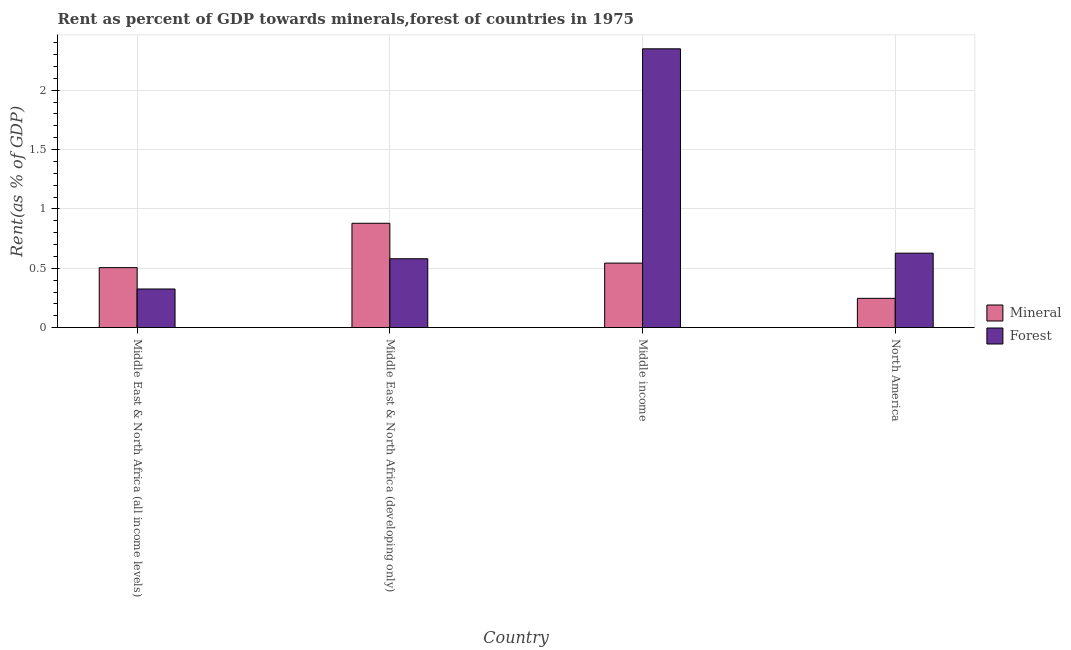How many different coloured bars are there?
Offer a terse response. 2. Are the number of bars per tick equal to the number of legend labels?
Your answer should be compact. Yes. Are the number of bars on each tick of the X-axis equal?
Offer a terse response. Yes. How many bars are there on the 3rd tick from the left?
Provide a succinct answer. 2. How many bars are there on the 4th tick from the right?
Provide a short and direct response. 2. What is the label of the 2nd group of bars from the left?
Offer a very short reply. Middle East & North Africa (developing only). What is the forest rent in Middle East & North Africa (all income levels)?
Give a very brief answer. 0.33. Across all countries, what is the maximum forest rent?
Give a very brief answer. 2.35. Across all countries, what is the minimum mineral rent?
Offer a terse response. 0.25. In which country was the mineral rent maximum?
Your response must be concise. Middle East & North Africa (developing only). In which country was the forest rent minimum?
Make the answer very short. Middle East & North Africa (all income levels). What is the total mineral rent in the graph?
Your answer should be very brief. 2.18. What is the difference between the mineral rent in Middle East & North Africa (all income levels) and that in Middle income?
Offer a very short reply. -0.04. What is the difference between the mineral rent in Middle East & North Africa (all income levels) and the forest rent in North America?
Offer a terse response. -0.12. What is the average forest rent per country?
Provide a succinct answer. 0.97. What is the difference between the mineral rent and forest rent in North America?
Give a very brief answer. -0.38. What is the ratio of the forest rent in Middle East & North Africa (developing only) to that in Middle income?
Provide a short and direct response. 0.25. What is the difference between the highest and the second highest forest rent?
Ensure brevity in your answer.  1.72. What is the difference between the highest and the lowest forest rent?
Provide a succinct answer. 2.02. In how many countries, is the forest rent greater than the average forest rent taken over all countries?
Provide a short and direct response. 1. Is the sum of the mineral rent in Middle income and North America greater than the maximum forest rent across all countries?
Keep it short and to the point. No. What does the 1st bar from the left in Middle East & North Africa (all income levels) represents?
Provide a short and direct response. Mineral. What does the 1st bar from the right in North America represents?
Ensure brevity in your answer.  Forest. What is the difference between two consecutive major ticks on the Y-axis?
Your response must be concise. 0.5. Are the values on the major ticks of Y-axis written in scientific E-notation?
Ensure brevity in your answer.  No. Does the graph contain grids?
Your answer should be compact. Yes. Where does the legend appear in the graph?
Give a very brief answer. Center right. How are the legend labels stacked?
Offer a terse response. Vertical. What is the title of the graph?
Ensure brevity in your answer.  Rent as percent of GDP towards minerals,forest of countries in 1975. Does "Automatic Teller Machines" appear as one of the legend labels in the graph?
Make the answer very short. No. What is the label or title of the Y-axis?
Provide a succinct answer. Rent(as % of GDP). What is the Rent(as % of GDP) in Mineral in Middle East & North Africa (all income levels)?
Make the answer very short. 0.51. What is the Rent(as % of GDP) in Forest in Middle East & North Africa (all income levels)?
Provide a short and direct response. 0.33. What is the Rent(as % of GDP) in Mineral in Middle East & North Africa (developing only)?
Keep it short and to the point. 0.88. What is the Rent(as % of GDP) in Forest in Middle East & North Africa (developing only)?
Your answer should be very brief. 0.58. What is the Rent(as % of GDP) of Mineral in Middle income?
Keep it short and to the point. 0.54. What is the Rent(as % of GDP) in Forest in Middle income?
Ensure brevity in your answer.  2.35. What is the Rent(as % of GDP) in Mineral in North America?
Give a very brief answer. 0.25. What is the Rent(as % of GDP) in Forest in North America?
Ensure brevity in your answer.  0.63. Across all countries, what is the maximum Rent(as % of GDP) of Mineral?
Keep it short and to the point. 0.88. Across all countries, what is the maximum Rent(as % of GDP) in Forest?
Keep it short and to the point. 2.35. Across all countries, what is the minimum Rent(as % of GDP) of Mineral?
Make the answer very short. 0.25. Across all countries, what is the minimum Rent(as % of GDP) in Forest?
Your response must be concise. 0.33. What is the total Rent(as % of GDP) in Mineral in the graph?
Keep it short and to the point. 2.17. What is the total Rent(as % of GDP) of Forest in the graph?
Make the answer very short. 3.88. What is the difference between the Rent(as % of GDP) of Mineral in Middle East & North Africa (all income levels) and that in Middle East & North Africa (developing only)?
Your answer should be compact. -0.37. What is the difference between the Rent(as % of GDP) of Forest in Middle East & North Africa (all income levels) and that in Middle East & North Africa (developing only)?
Offer a very short reply. -0.25. What is the difference between the Rent(as % of GDP) of Mineral in Middle East & North Africa (all income levels) and that in Middle income?
Ensure brevity in your answer.  -0.04. What is the difference between the Rent(as % of GDP) of Forest in Middle East & North Africa (all income levels) and that in Middle income?
Keep it short and to the point. -2.02. What is the difference between the Rent(as % of GDP) of Mineral in Middle East & North Africa (all income levels) and that in North America?
Your answer should be very brief. 0.26. What is the difference between the Rent(as % of GDP) of Forest in Middle East & North Africa (all income levels) and that in North America?
Your response must be concise. -0.3. What is the difference between the Rent(as % of GDP) in Mineral in Middle East & North Africa (developing only) and that in Middle income?
Provide a succinct answer. 0.34. What is the difference between the Rent(as % of GDP) of Forest in Middle East & North Africa (developing only) and that in Middle income?
Ensure brevity in your answer.  -1.77. What is the difference between the Rent(as % of GDP) in Mineral in Middle East & North Africa (developing only) and that in North America?
Offer a very short reply. 0.63. What is the difference between the Rent(as % of GDP) of Forest in Middle East & North Africa (developing only) and that in North America?
Keep it short and to the point. -0.05. What is the difference between the Rent(as % of GDP) of Mineral in Middle income and that in North America?
Provide a succinct answer. 0.3. What is the difference between the Rent(as % of GDP) of Forest in Middle income and that in North America?
Give a very brief answer. 1.72. What is the difference between the Rent(as % of GDP) in Mineral in Middle East & North Africa (all income levels) and the Rent(as % of GDP) in Forest in Middle East & North Africa (developing only)?
Offer a terse response. -0.07. What is the difference between the Rent(as % of GDP) of Mineral in Middle East & North Africa (all income levels) and the Rent(as % of GDP) of Forest in Middle income?
Offer a terse response. -1.84. What is the difference between the Rent(as % of GDP) of Mineral in Middle East & North Africa (all income levels) and the Rent(as % of GDP) of Forest in North America?
Make the answer very short. -0.12. What is the difference between the Rent(as % of GDP) of Mineral in Middle East & North Africa (developing only) and the Rent(as % of GDP) of Forest in Middle income?
Provide a short and direct response. -1.47. What is the difference between the Rent(as % of GDP) of Mineral in Middle East & North Africa (developing only) and the Rent(as % of GDP) of Forest in North America?
Make the answer very short. 0.25. What is the difference between the Rent(as % of GDP) in Mineral in Middle income and the Rent(as % of GDP) in Forest in North America?
Your response must be concise. -0.08. What is the average Rent(as % of GDP) in Mineral per country?
Make the answer very short. 0.54. What is the average Rent(as % of GDP) in Forest per country?
Your response must be concise. 0.97. What is the difference between the Rent(as % of GDP) of Mineral and Rent(as % of GDP) of Forest in Middle East & North Africa (all income levels)?
Provide a succinct answer. 0.18. What is the difference between the Rent(as % of GDP) of Mineral and Rent(as % of GDP) of Forest in Middle East & North Africa (developing only)?
Your response must be concise. 0.3. What is the difference between the Rent(as % of GDP) of Mineral and Rent(as % of GDP) of Forest in Middle income?
Keep it short and to the point. -1.8. What is the difference between the Rent(as % of GDP) of Mineral and Rent(as % of GDP) of Forest in North America?
Offer a very short reply. -0.38. What is the ratio of the Rent(as % of GDP) of Mineral in Middle East & North Africa (all income levels) to that in Middle East & North Africa (developing only)?
Ensure brevity in your answer.  0.57. What is the ratio of the Rent(as % of GDP) in Forest in Middle East & North Africa (all income levels) to that in Middle East & North Africa (developing only)?
Your response must be concise. 0.56. What is the ratio of the Rent(as % of GDP) in Mineral in Middle East & North Africa (all income levels) to that in Middle income?
Keep it short and to the point. 0.93. What is the ratio of the Rent(as % of GDP) in Forest in Middle East & North Africa (all income levels) to that in Middle income?
Your response must be concise. 0.14. What is the ratio of the Rent(as % of GDP) in Mineral in Middle East & North Africa (all income levels) to that in North America?
Offer a very short reply. 2.05. What is the ratio of the Rent(as % of GDP) in Forest in Middle East & North Africa (all income levels) to that in North America?
Ensure brevity in your answer.  0.52. What is the ratio of the Rent(as % of GDP) in Mineral in Middle East & North Africa (developing only) to that in Middle income?
Provide a succinct answer. 1.62. What is the ratio of the Rent(as % of GDP) in Forest in Middle East & North Africa (developing only) to that in Middle income?
Make the answer very short. 0.25. What is the ratio of the Rent(as % of GDP) in Mineral in Middle East & North Africa (developing only) to that in North America?
Give a very brief answer. 3.56. What is the ratio of the Rent(as % of GDP) in Forest in Middle East & North Africa (developing only) to that in North America?
Keep it short and to the point. 0.93. What is the ratio of the Rent(as % of GDP) of Mineral in Middle income to that in North America?
Your response must be concise. 2.2. What is the ratio of the Rent(as % of GDP) of Forest in Middle income to that in North America?
Give a very brief answer. 3.74. What is the difference between the highest and the second highest Rent(as % of GDP) in Mineral?
Your response must be concise. 0.34. What is the difference between the highest and the second highest Rent(as % of GDP) in Forest?
Offer a very short reply. 1.72. What is the difference between the highest and the lowest Rent(as % of GDP) of Mineral?
Offer a very short reply. 0.63. What is the difference between the highest and the lowest Rent(as % of GDP) in Forest?
Provide a succinct answer. 2.02. 